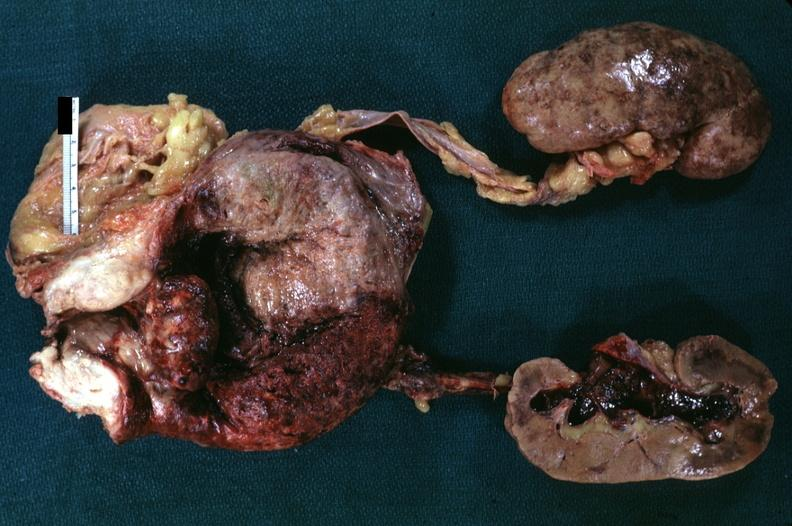what is pyelonephritis carcinoma in prostate?
Answer the question using a single word or phrase. Diagnosis 